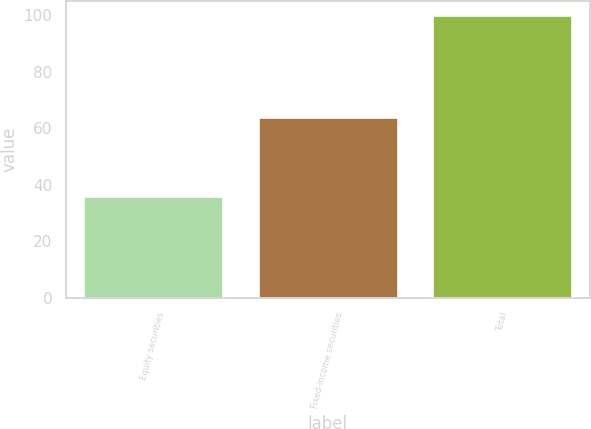Convert chart to OTSL. <chart><loc_0><loc_0><loc_500><loc_500><bar_chart><fcel>Equity securities<fcel>Fixed-income securities<fcel>Total<nl><fcel>36<fcel>64<fcel>100<nl></chart> 